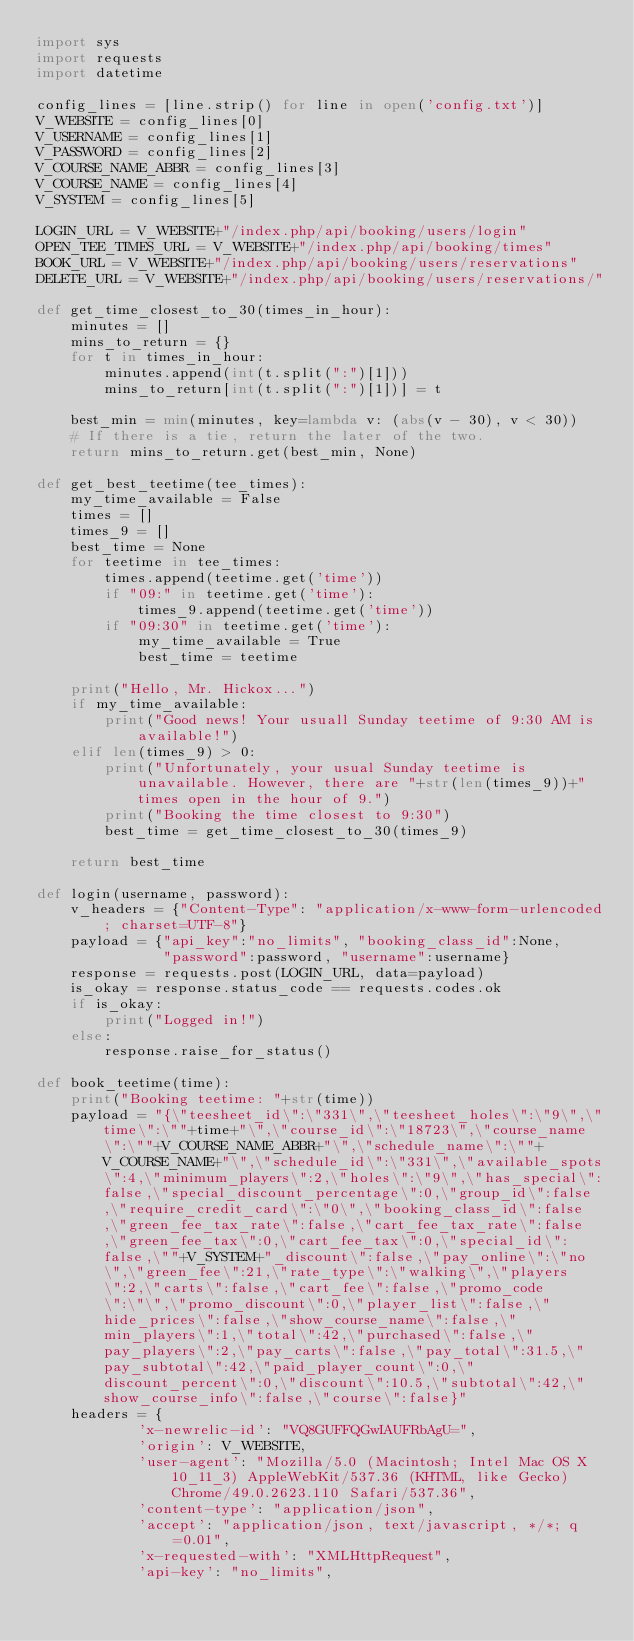<code> <loc_0><loc_0><loc_500><loc_500><_Python_>import sys
import requests
import datetime

config_lines = [line.strip() for line in open('config.txt')]
V_WEBSITE = config_lines[0]
V_USERNAME = config_lines[1]
V_PASSWORD = config_lines[2]
V_COURSE_NAME_ABBR = config_lines[3]
V_COURSE_NAME = config_lines[4]
V_SYSTEM = config_lines[5]

LOGIN_URL = V_WEBSITE+"/index.php/api/booking/users/login"
OPEN_TEE_TIMES_URL = V_WEBSITE+"/index.php/api/booking/times"
BOOK_URL = V_WEBSITE+"/index.php/api/booking/users/reservations"
DELETE_URL = V_WEBSITE+"/index.php/api/booking/users/reservations/"

def get_time_closest_to_30(times_in_hour):
    minutes = []
    mins_to_return = {}
    for t in times_in_hour:
        minutes.append(int(t.split(":")[1]))
        mins_to_return[int(t.split(":")[1])] = t

    best_min = min(minutes, key=lambda v: (abs(v - 30), v < 30))
    # If there is a tie, return the later of the two.
    return mins_to_return.get(best_min, None)

def get_best_teetime(tee_times):
    my_time_available = False
    times = []
    times_9 = []
    best_time = None
    for teetime in tee_times:
        times.append(teetime.get('time'))
        if "09:" in teetime.get('time'):
            times_9.append(teetime.get('time'))
        if "09:30" in teetime.get('time'):
            my_time_available = True
            best_time = teetime

    print("Hello, Mr. Hickox...")
    if my_time_available:
        print("Good news! Your usuall Sunday teetime of 9:30 AM is available!")
    elif len(times_9) > 0: 
        print("Unfortunately, your usual Sunday teetime is unavailable. However, there are "+str(len(times_9))+" times open in the hour of 9.")
        print("Booking the time closest to 9:30")
        best_time = get_time_closest_to_30(times_9)

    return best_time
              
def login(username, password):
    v_headers = {"Content-Type": "application/x-www-form-urlencoded; charset=UTF-8"}
    payload = {"api_key":"no_limits", "booking_class_id":None,
               "password":password, "username":username}
    response = requests.post(LOGIN_URL, data=payload)
    is_okay = response.status_code == requests.codes.ok
    if is_okay:
        print("Logged in!")
    else:
        response.raise_for_status()

def book_teetime(time):
    print("Booking teetime: "+str(time))
    payload = "{\"teesheet_id\":\"331\",\"teesheet_holes\":\"9\",\"time\":\""+time+"\",\"course_id\":\"18723\",\"course_name\":\""+V_COURSE_NAME_ABBR+"\",\"schedule_name\":\""+V_COURSE_NAME+"\",\"schedule_id\":\"331\",\"available_spots\":4,\"minimum_players\":2,\"holes\":\"9\",\"has_special\":false,\"special_discount_percentage\":0,\"group_id\":false,\"require_credit_card\":\"0\",\"booking_class_id\":false,\"green_fee_tax_rate\":false,\"cart_fee_tax_rate\":false,\"green_fee_tax\":0,\"cart_fee_tax\":0,\"special_id\":false,\""+V_SYSTEM+"_discount\":false,\"pay_online\":\"no\",\"green_fee\":21,\"rate_type\":\"walking\",\"players\":2,\"carts\":false,\"cart_fee\":false,\"promo_code\":\"\",\"promo_discount\":0,\"player_list\":false,\"hide_prices\":false,\"show_course_name\":false,\"min_players\":1,\"total\":42,\"purchased\":false,\"pay_players\":2,\"pay_carts\":false,\"pay_total\":31.5,\"pay_subtotal\":42,\"paid_player_count\":0,\"discount_percent\":0,\"discount\":10.5,\"subtotal\":42,\"show_course_info\":false,\"course\":false}"
    headers = {
            'x-newrelic-id': "VQ8GUFFQGwIAUFRbAgU=",
            'origin': V_WEBSITE,
            'user-agent': "Mozilla/5.0 (Macintosh; Intel Mac OS X 10_11_3) AppleWebKit/537.36 (KHTML, like Gecko) Chrome/49.0.2623.110 Safari/537.36",
            'content-type': "application/json",
            'accept': "application/json, text/javascript, */*; q=0.01",
            'x-requested-with': "XMLHttpRequest",
            'api-key': "no_limits",</code> 